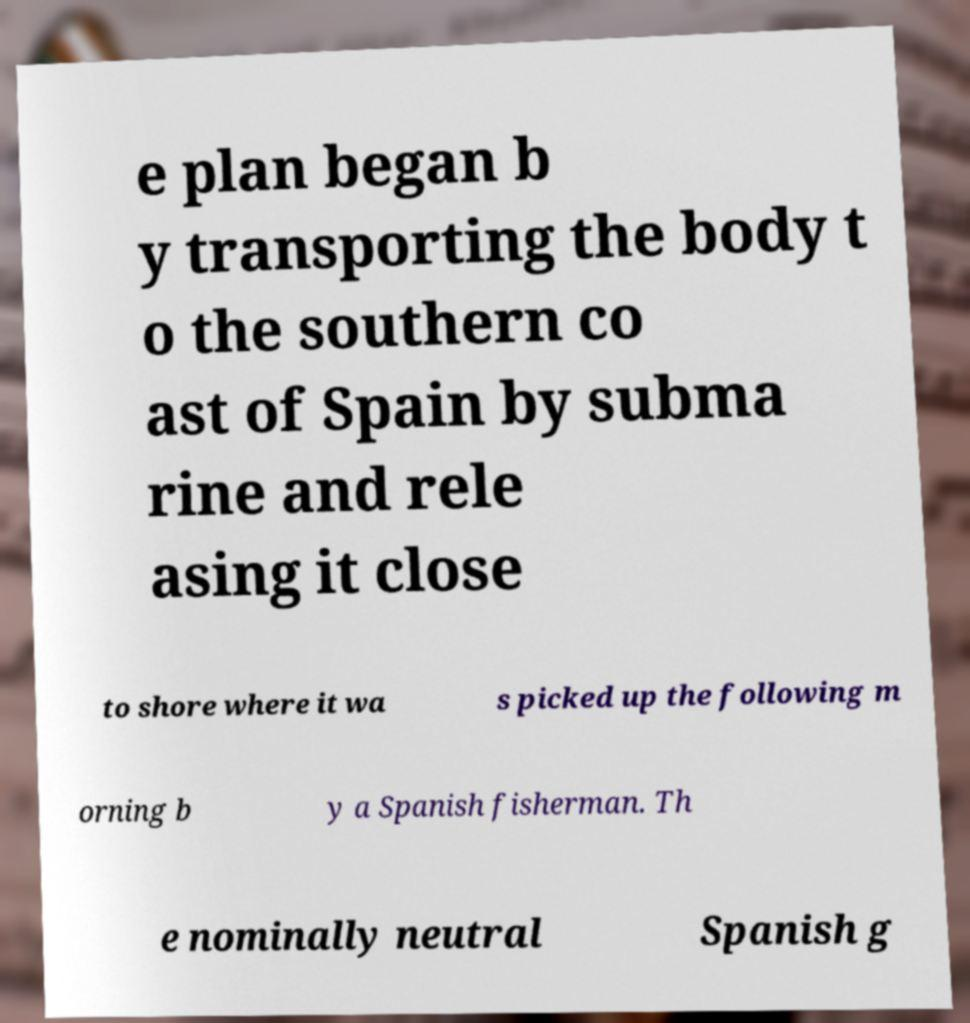There's text embedded in this image that I need extracted. Can you transcribe it verbatim? e plan began b y transporting the body t o the southern co ast of Spain by subma rine and rele asing it close to shore where it wa s picked up the following m orning b y a Spanish fisherman. Th e nominally neutral Spanish g 